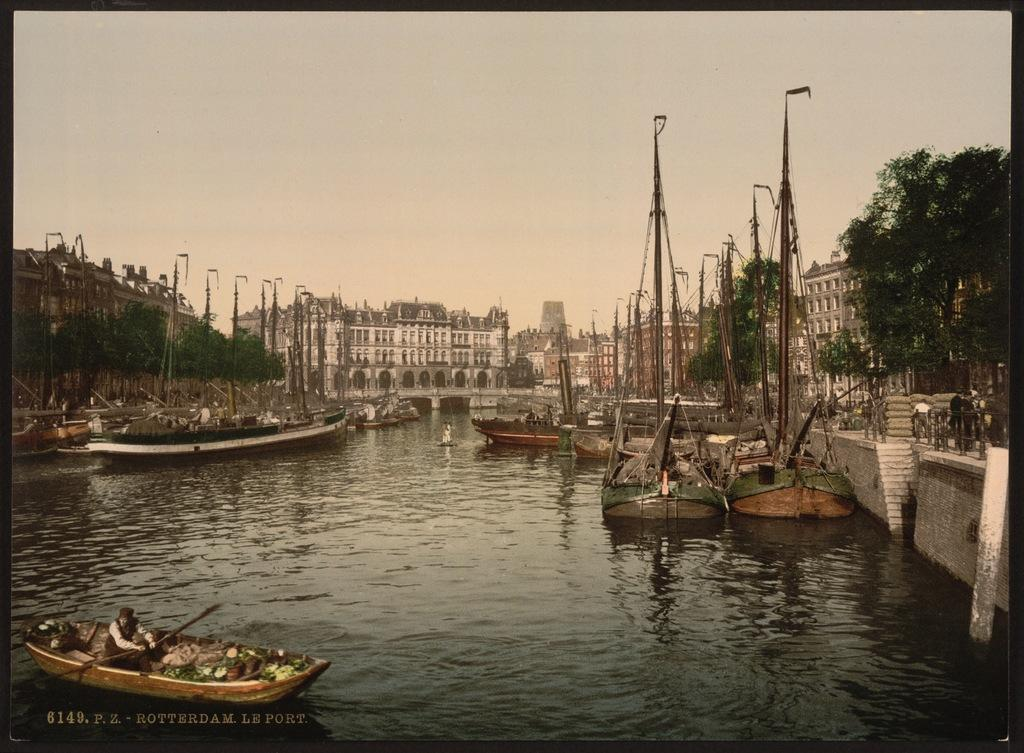What is on the water in the image? There are boats on the water in the image. Who or what is present in the image besides the boats? There is a group of people and buildings in the image. What type of vegetation can be seen in the image? There are trees in the image. What is visible in the background of the image? The sky is visible in the background of the image. Can you describe any additional features of the image? There is a watermark on the image. What type of heart-shaped object can be seen in the image? There is no heart-shaped object present in the image. How does the behavior of the people in the image change throughout the trip? There is no trip or change in behavior mentioned in the image; it simply shows a group of people, boats, buildings, trees, and the sky. 